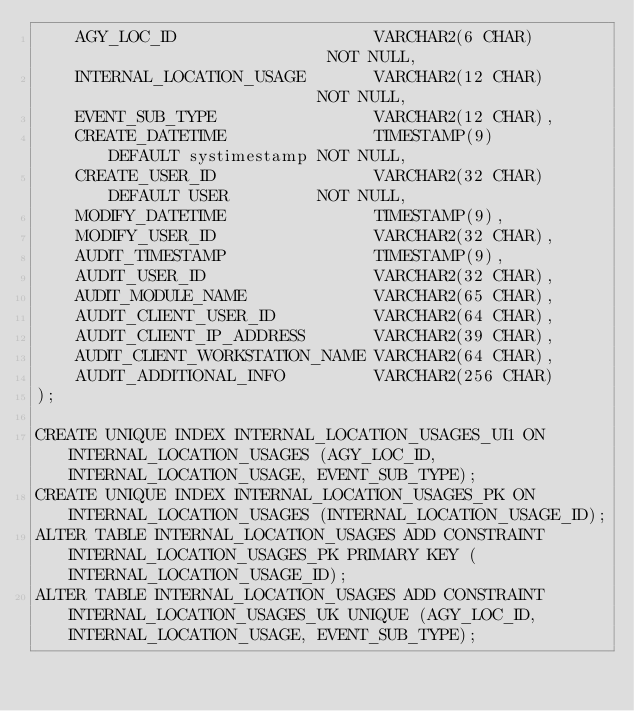Convert code to text. <code><loc_0><loc_0><loc_500><loc_500><_SQL_>    AGY_LOC_ID                    VARCHAR2(6 CHAR)                       NOT NULL,
    INTERNAL_LOCATION_USAGE       VARCHAR2(12 CHAR)                      NOT NULL,
    EVENT_SUB_TYPE                VARCHAR2(12 CHAR),
    CREATE_DATETIME               TIMESTAMP(9)      DEFAULT systimestamp NOT NULL,
    CREATE_USER_ID                VARCHAR2(32 CHAR) DEFAULT USER         NOT NULL,
    MODIFY_DATETIME               TIMESTAMP(9),
    MODIFY_USER_ID                VARCHAR2(32 CHAR),
    AUDIT_TIMESTAMP               TIMESTAMP(9),
    AUDIT_USER_ID                 VARCHAR2(32 CHAR),
    AUDIT_MODULE_NAME             VARCHAR2(65 CHAR),
    AUDIT_CLIENT_USER_ID          VARCHAR2(64 CHAR),
    AUDIT_CLIENT_IP_ADDRESS       VARCHAR2(39 CHAR),
    AUDIT_CLIENT_WORKSTATION_NAME VARCHAR2(64 CHAR),
    AUDIT_ADDITIONAL_INFO         VARCHAR2(256 CHAR)
);

CREATE UNIQUE INDEX INTERNAL_LOCATION_USAGES_UI1 ON INTERNAL_LOCATION_USAGES (AGY_LOC_ID, INTERNAL_LOCATION_USAGE, EVENT_SUB_TYPE);
CREATE UNIQUE INDEX INTERNAL_LOCATION_USAGES_PK ON INTERNAL_LOCATION_USAGES (INTERNAL_LOCATION_USAGE_ID);
ALTER TABLE INTERNAL_LOCATION_USAGES ADD CONSTRAINT INTERNAL_LOCATION_USAGES_PK PRIMARY KEY (INTERNAL_LOCATION_USAGE_ID);
ALTER TABLE INTERNAL_LOCATION_USAGES ADD CONSTRAINT INTERNAL_LOCATION_USAGES_UK UNIQUE (AGY_LOC_ID, INTERNAL_LOCATION_USAGE, EVENT_SUB_TYPE);
</code> 